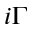Convert formula to latex. <formula><loc_0><loc_0><loc_500><loc_500>i \Gamma</formula> 